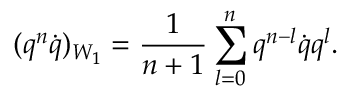Convert formula to latex. <formula><loc_0><loc_0><loc_500><loc_500>( q ^ { n } \dot { q } ) _ { W _ { 1 } } = \frac { 1 } n + 1 } \sum _ { l = 0 } ^ { n } q ^ { n - l } \dot { q } q ^ { l } .</formula> 